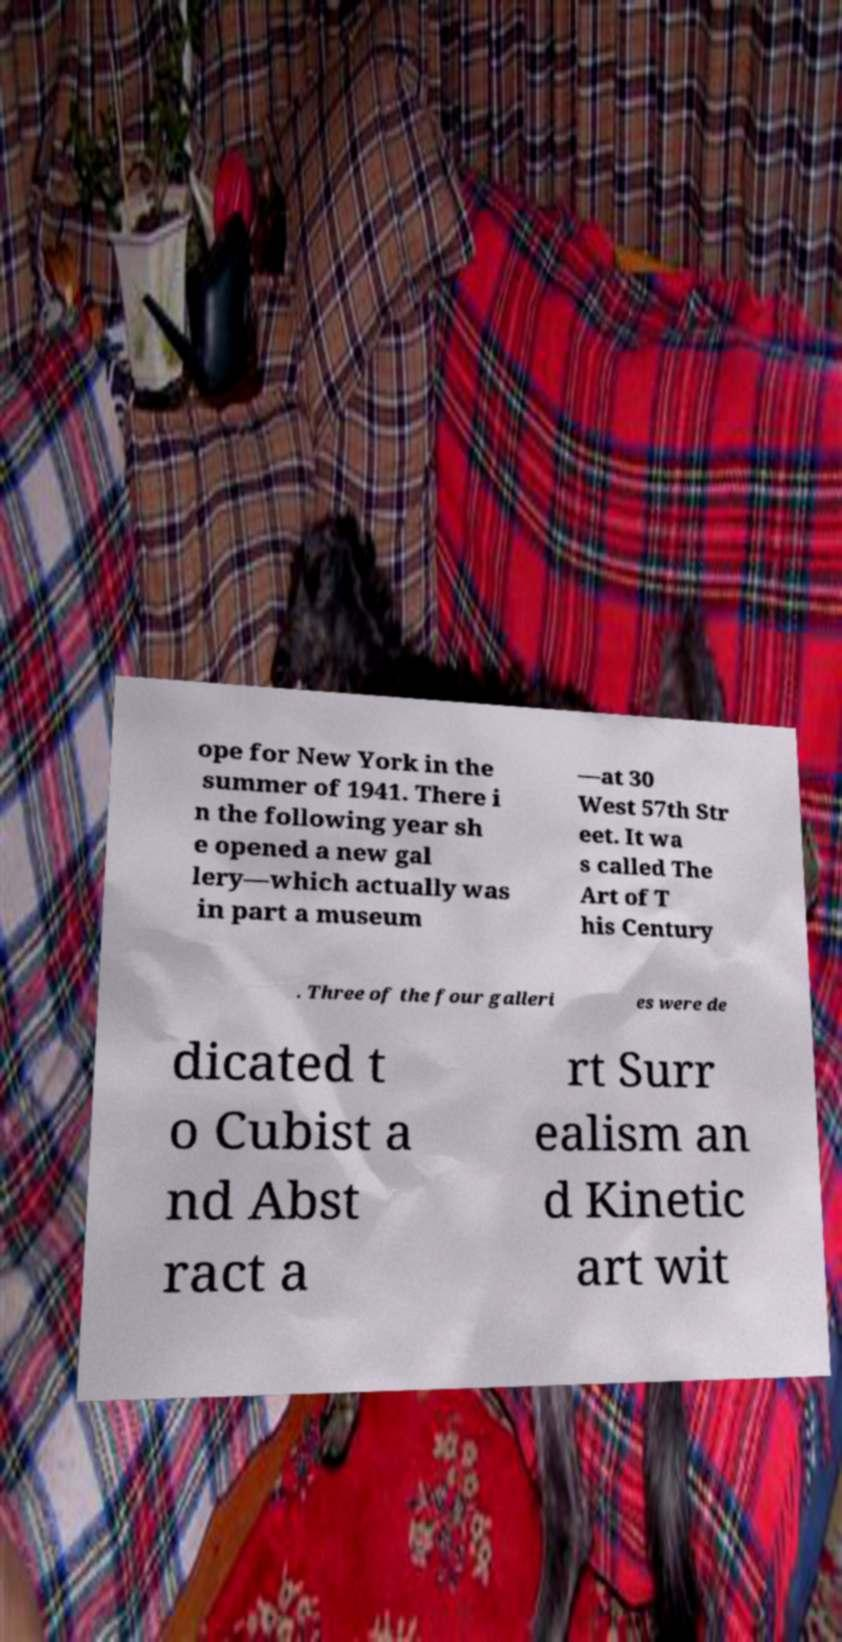Could you extract and type out the text from this image? ope for New York in the summer of 1941. There i n the following year sh e opened a new gal lery—which actually was in part a museum —at 30 West 57th Str eet. It wa s called The Art of T his Century . Three of the four galleri es were de dicated t o Cubist a nd Abst ract a rt Surr ealism an d Kinetic art wit 